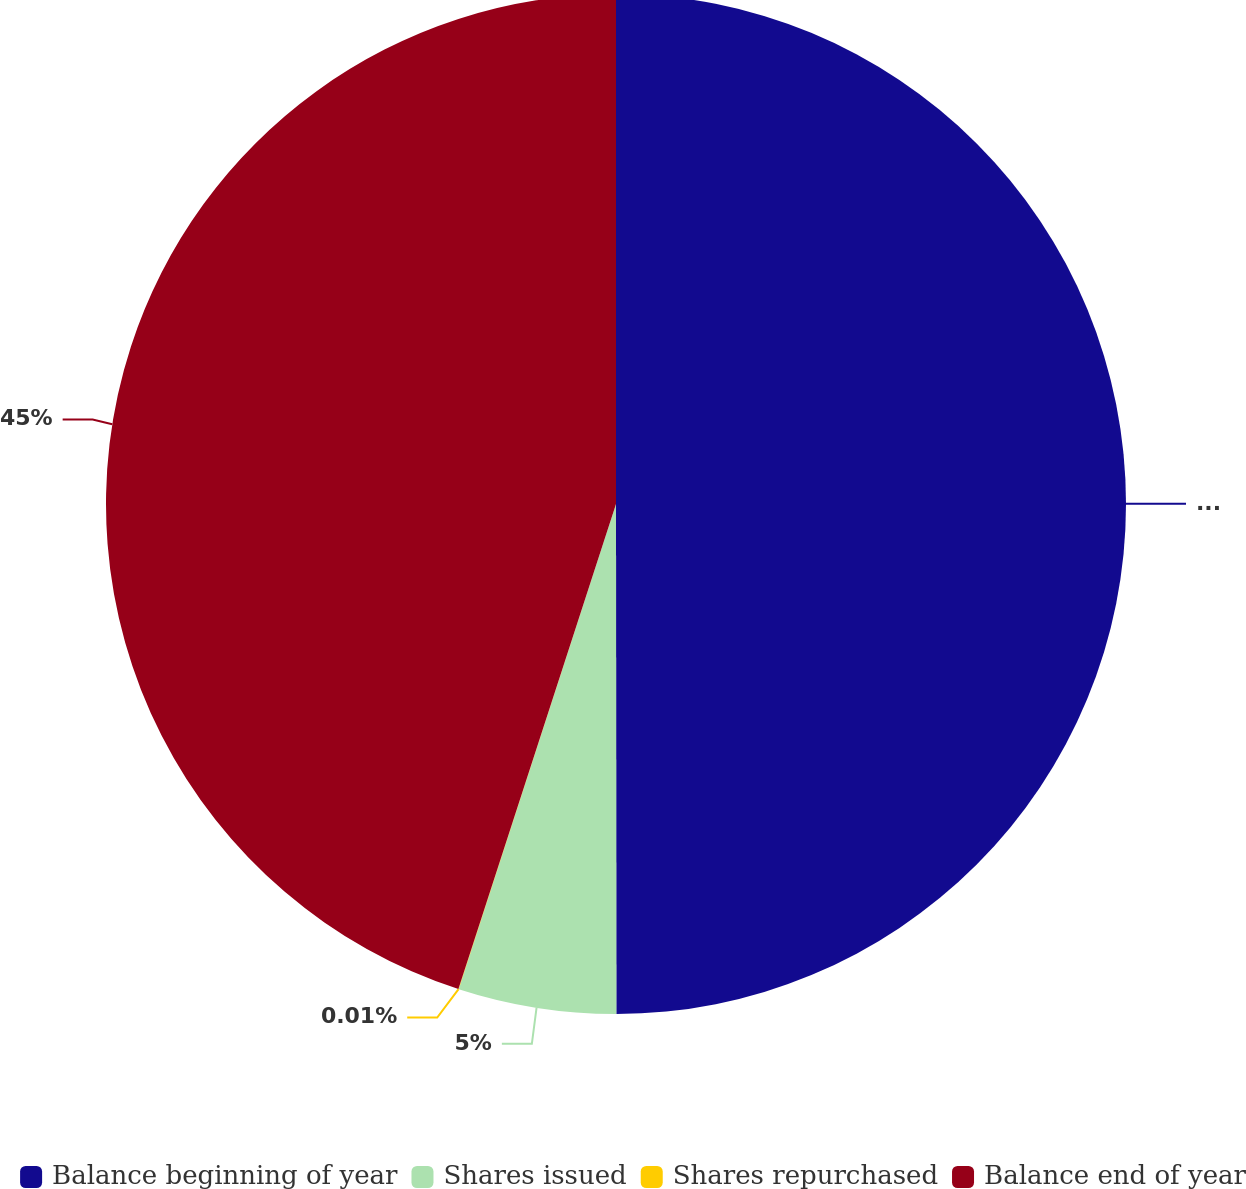<chart> <loc_0><loc_0><loc_500><loc_500><pie_chart><fcel>Balance beginning of year<fcel>Shares issued<fcel>Shares repurchased<fcel>Balance end of year<nl><fcel>49.99%<fcel>5.0%<fcel>0.01%<fcel>45.0%<nl></chart> 